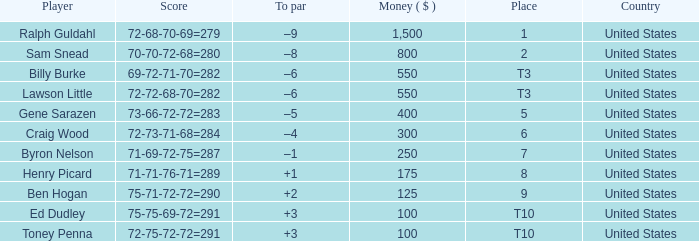Which country has a prize smaller than $250 and the player Henry Picard? United States. 